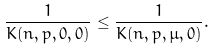<formula> <loc_0><loc_0><loc_500><loc_500>\frac { 1 } { K ( n , p , 0 , 0 ) } \leq \frac { 1 } { K ( n , p , \mu , 0 ) } .</formula> 